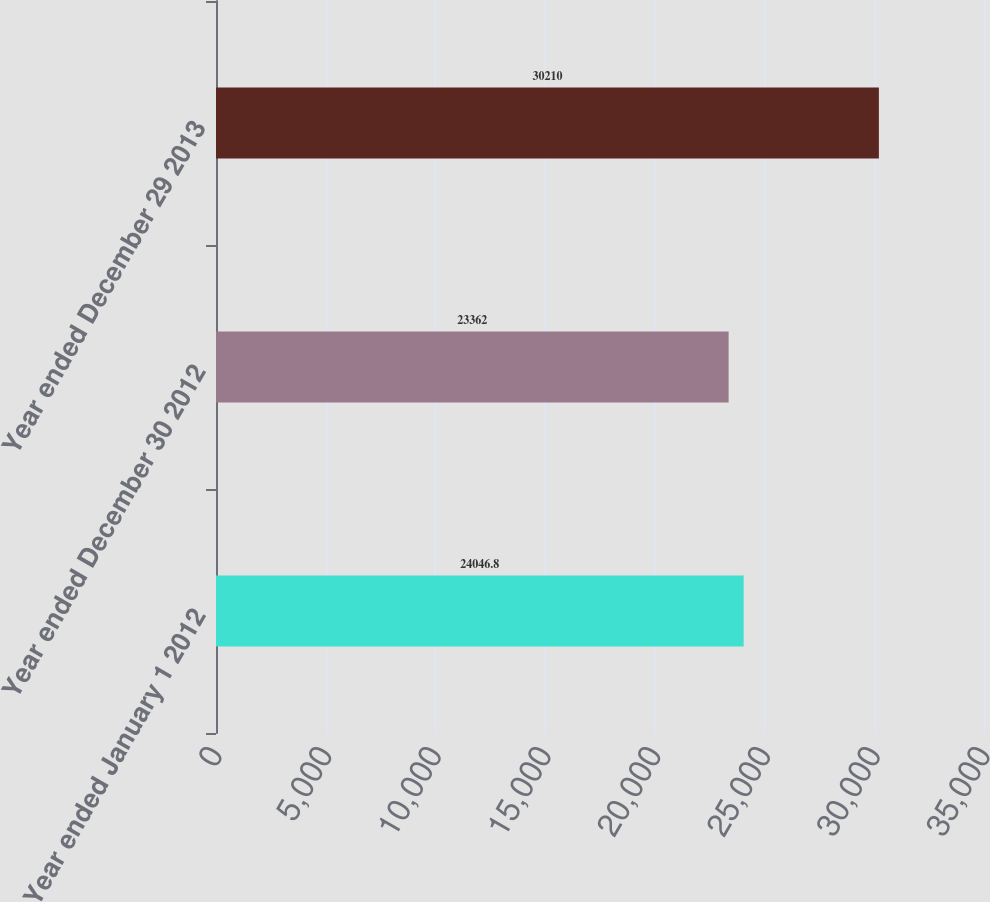Convert chart. <chart><loc_0><loc_0><loc_500><loc_500><bar_chart><fcel>Year ended January 1 2012<fcel>Year ended December 30 2012<fcel>Year ended December 29 2013<nl><fcel>24046.8<fcel>23362<fcel>30210<nl></chart> 